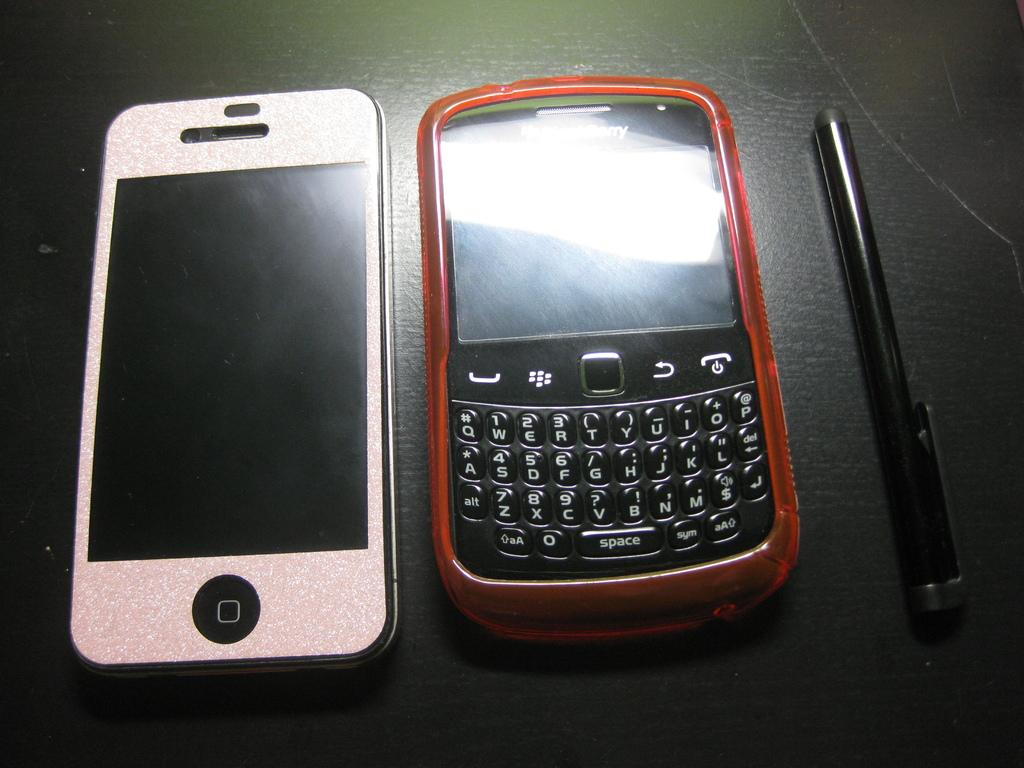<image>
Summarize the visual content of the image. Two cell phones, one Iphone and one Blackberry on a table with a stylus. 